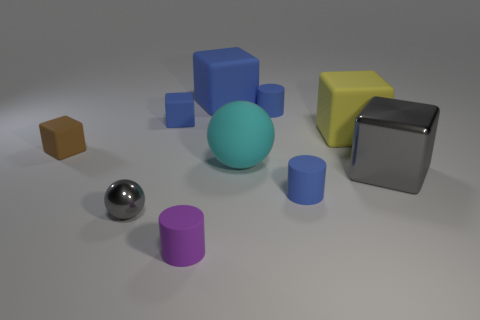Subtract all blue cylinders. How many cylinders are left? 1 Subtract all red balls. How many blue cylinders are left? 2 Subtract all gray balls. How many balls are left? 1 Subtract 2 blocks. How many blocks are left? 3 Subtract all cylinders. How many objects are left? 7 Subtract all tiny green metal cubes. Subtract all tiny blue things. How many objects are left? 7 Add 8 blue cylinders. How many blue cylinders are left? 10 Add 4 purple cylinders. How many purple cylinders exist? 5 Subtract 0 green cylinders. How many objects are left? 10 Subtract all green spheres. Subtract all gray cylinders. How many spheres are left? 2 